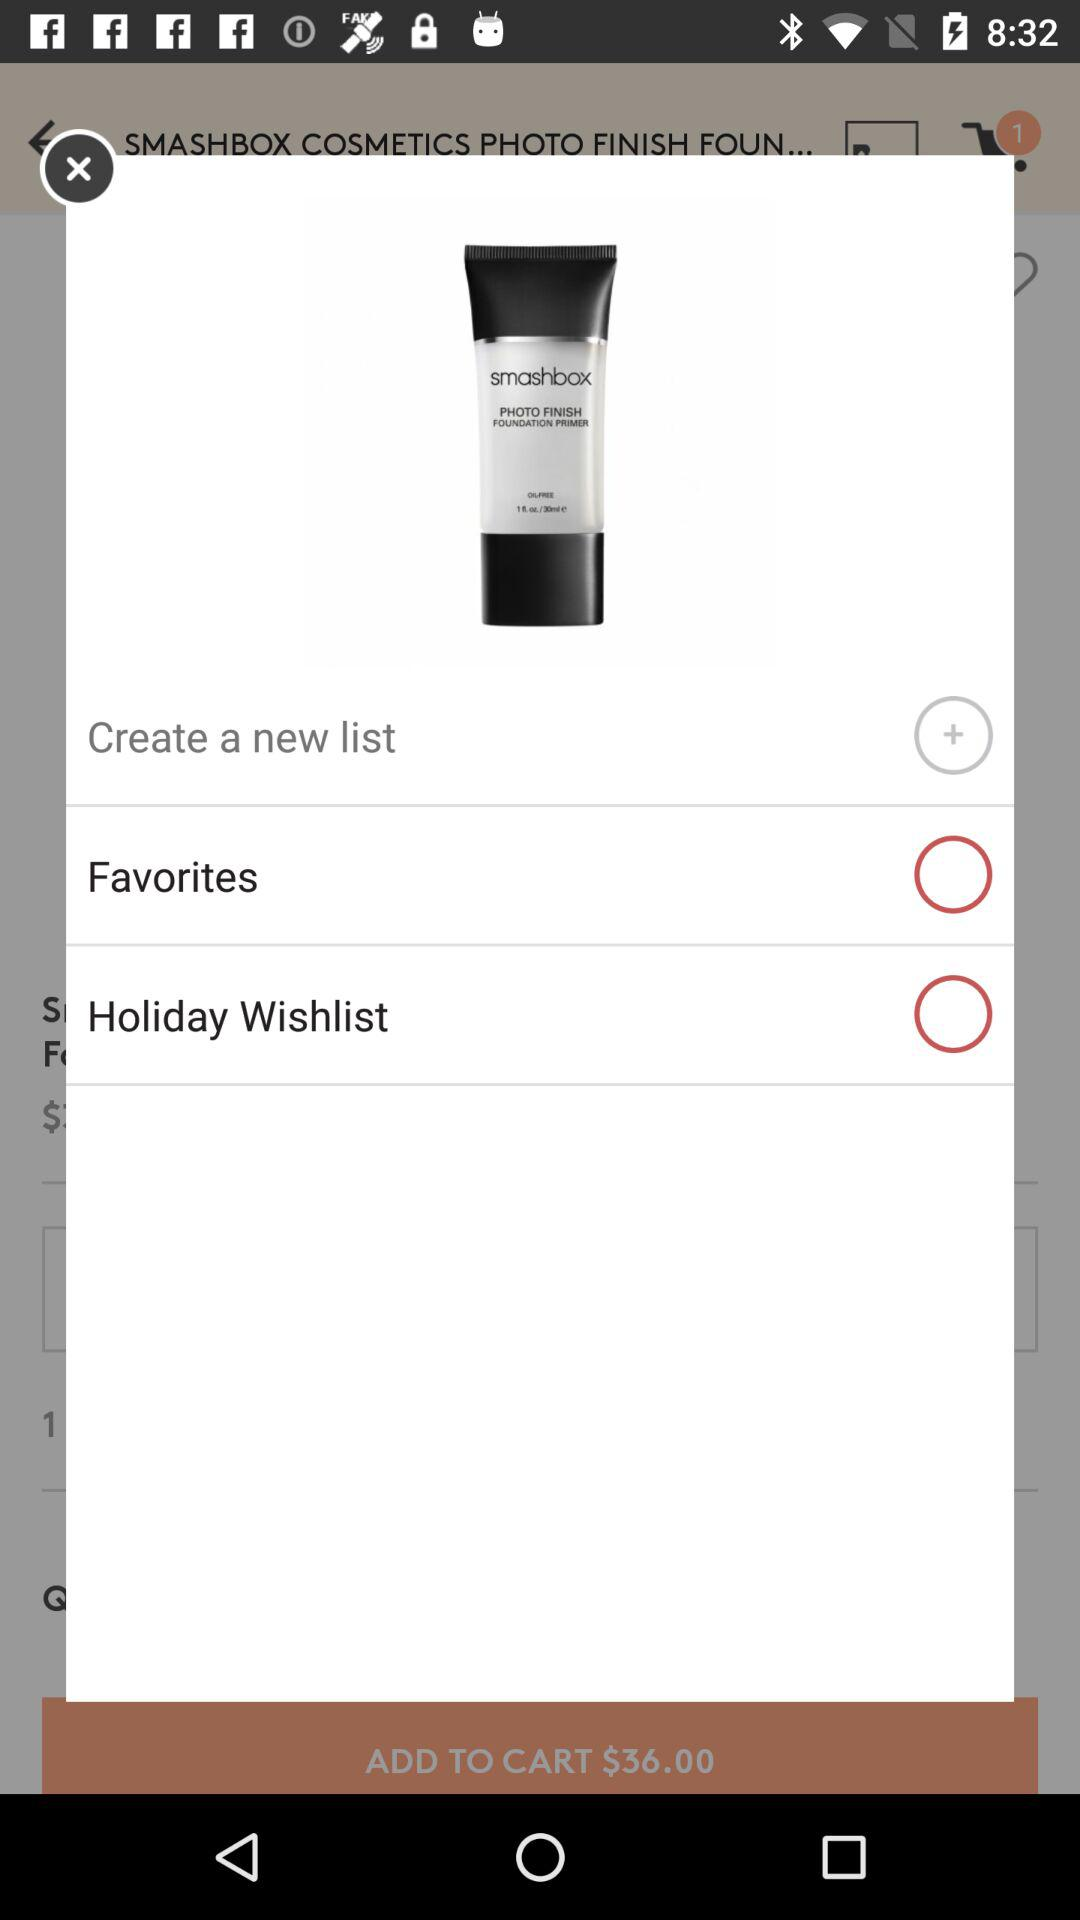What is the status of "Favorites"? The status is off. 